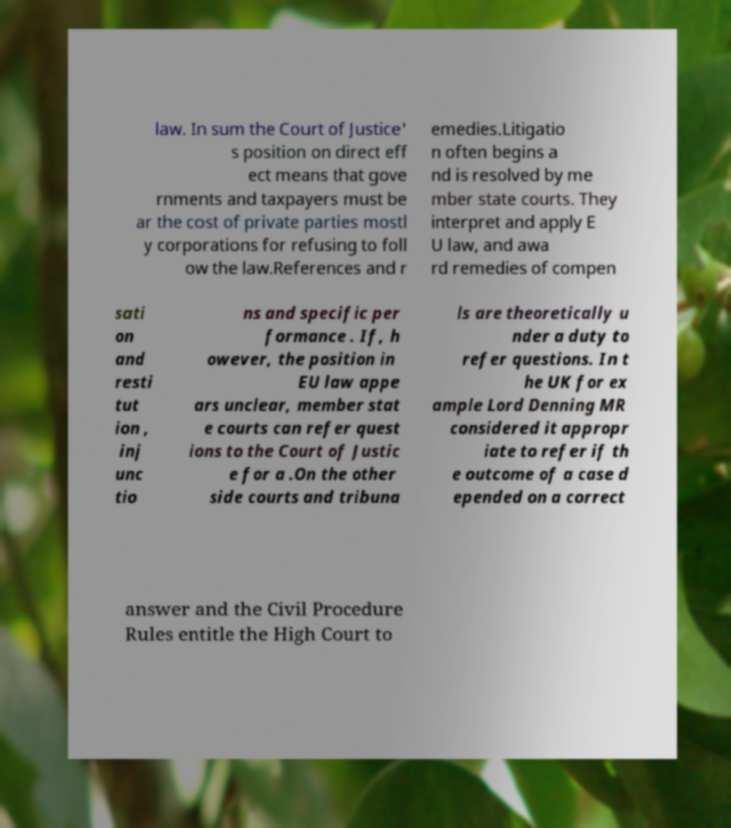I need the written content from this picture converted into text. Can you do that? law. In sum the Court of Justice' s position on direct eff ect means that gove rnments and taxpayers must be ar the cost of private parties mostl y corporations for refusing to foll ow the law.References and r emedies.Litigatio n often begins a nd is resolved by me mber state courts. They interpret and apply E U law, and awa rd remedies of compen sati on and resti tut ion , inj unc tio ns and specific per formance . If, h owever, the position in EU law appe ars unclear, member stat e courts can refer quest ions to the Court of Justic e for a .On the other side courts and tribuna ls are theoretically u nder a duty to refer questions. In t he UK for ex ample Lord Denning MR considered it appropr iate to refer if th e outcome of a case d epended on a correct answer and the Civil Procedure Rules entitle the High Court to 